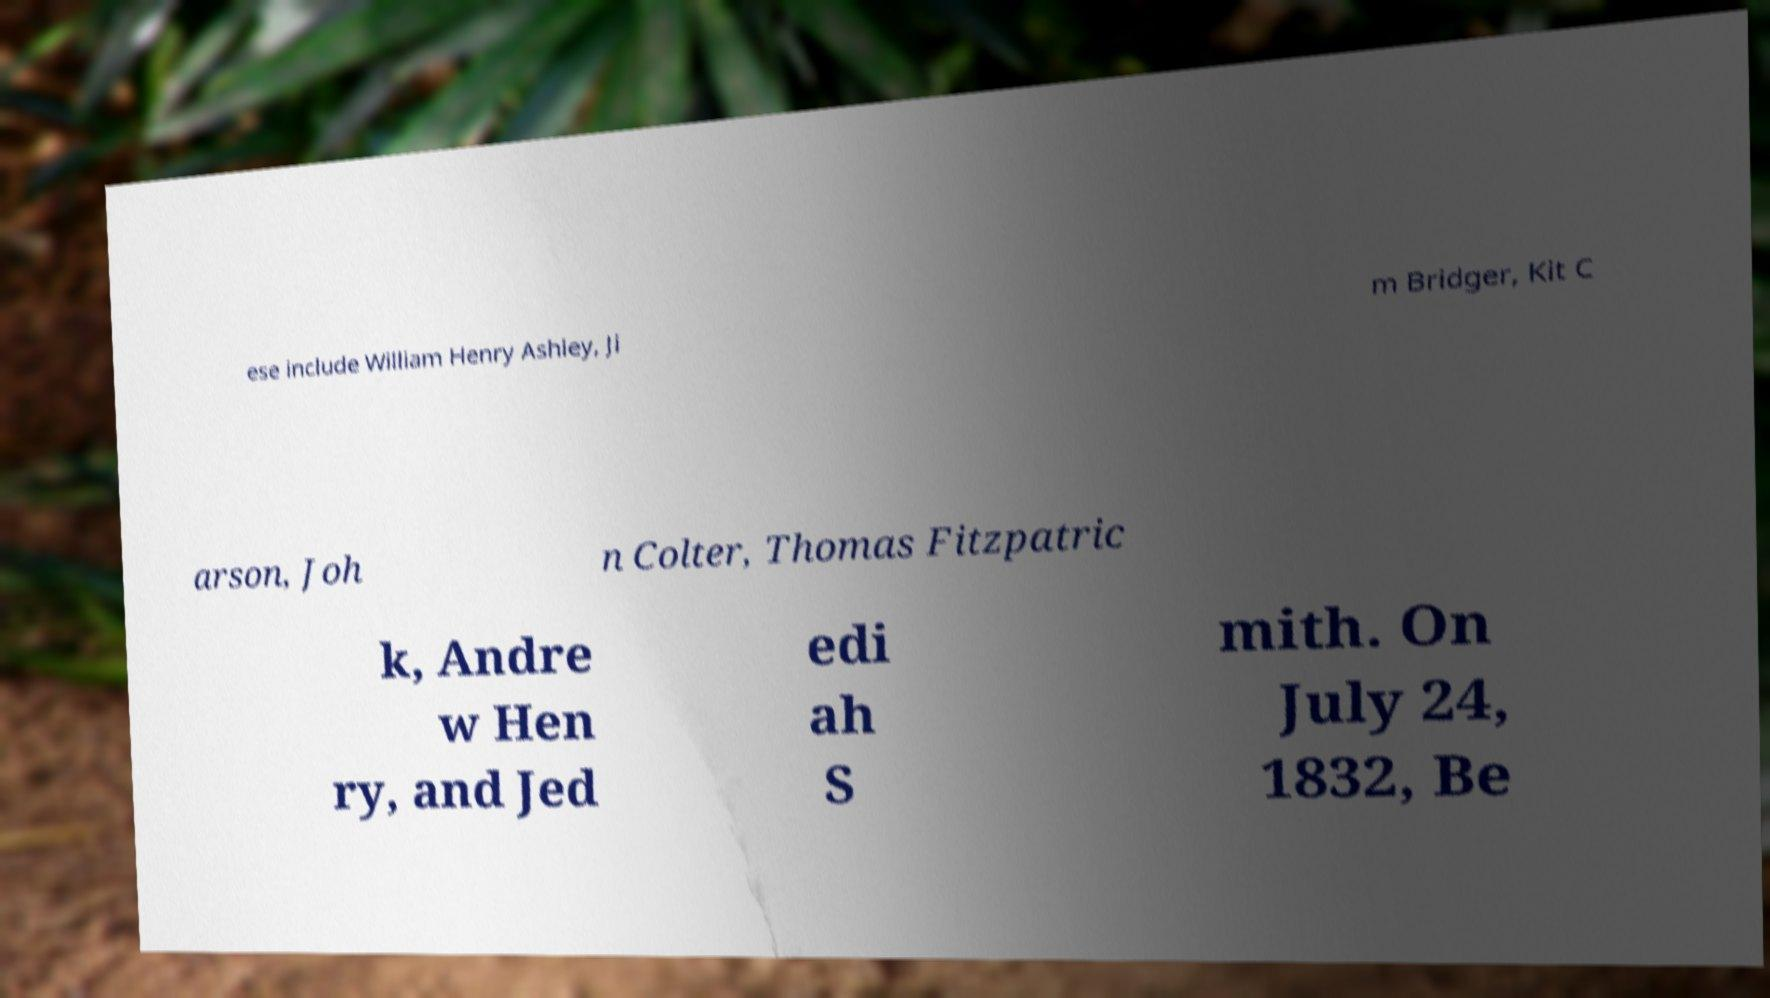There's text embedded in this image that I need extracted. Can you transcribe it verbatim? ese include William Henry Ashley, Ji m Bridger, Kit C arson, Joh n Colter, Thomas Fitzpatric k, Andre w Hen ry, and Jed edi ah S mith. On July 24, 1832, Be 